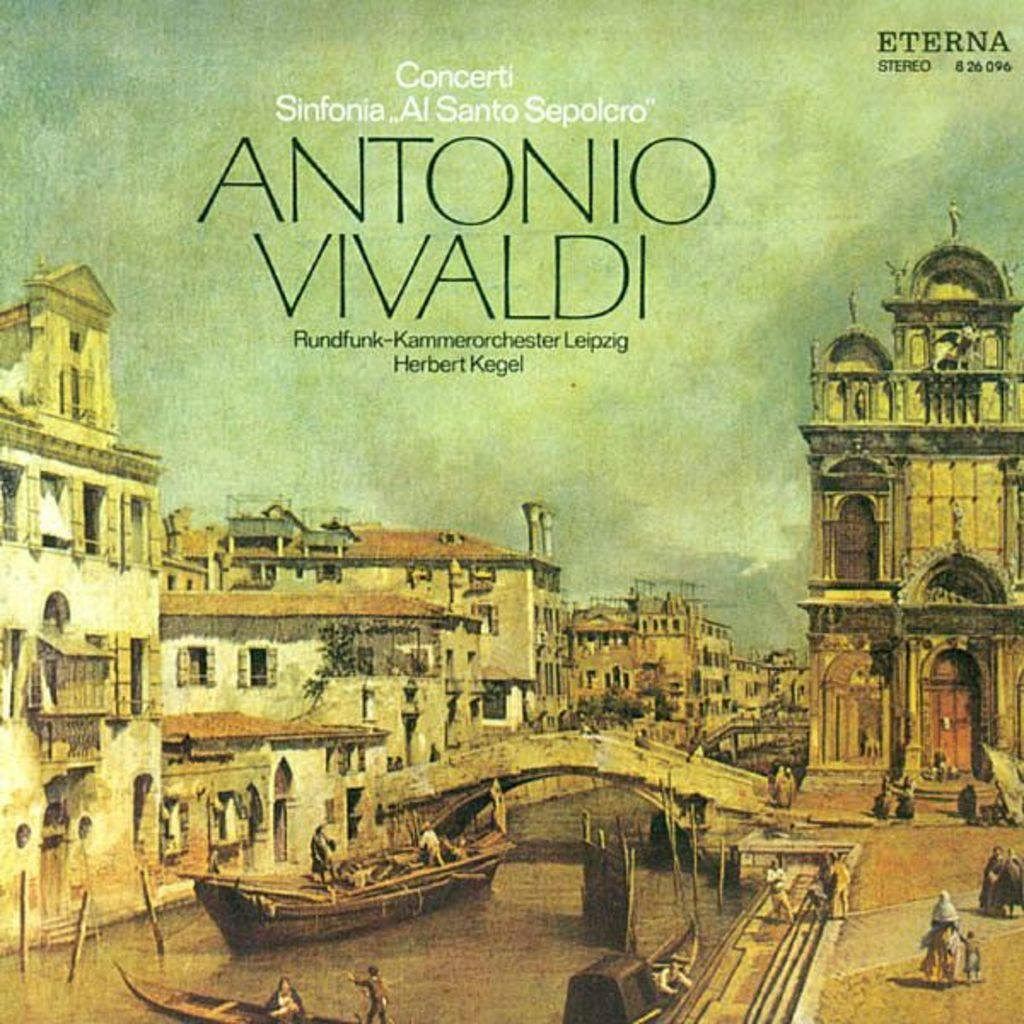<image>
Write a terse but informative summary of the picture. A record case for Antonio Vivaldi shows the iconic scene of people traveling in a Gondola in an Italian City. 